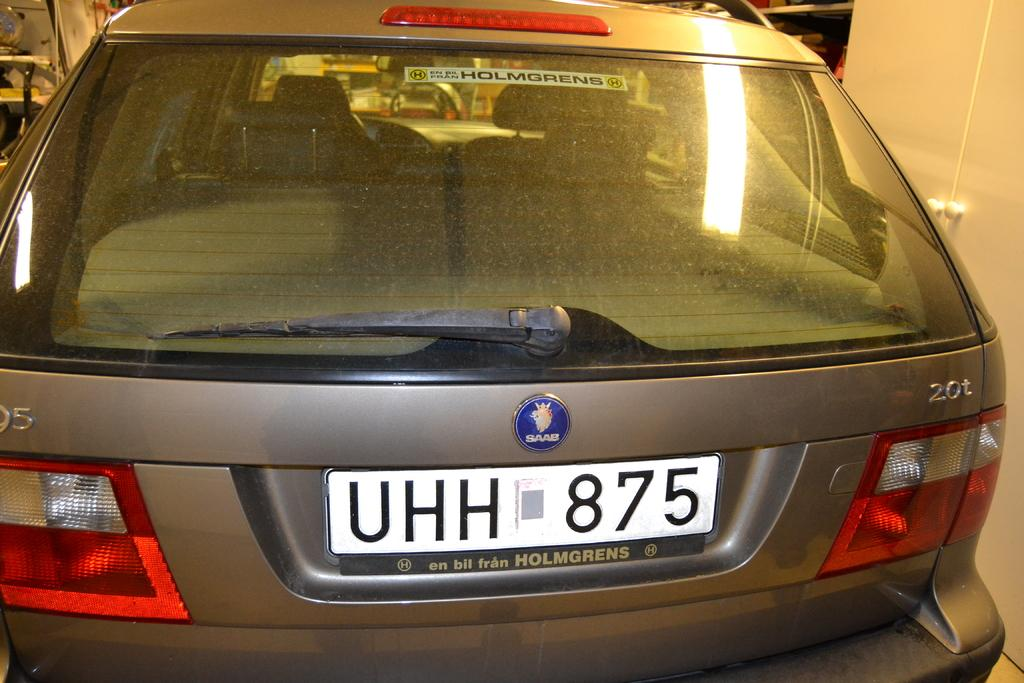<image>
Write a terse but informative summary of the picture. The back of a brownish silver colored Saab autombile parked in a garage. 